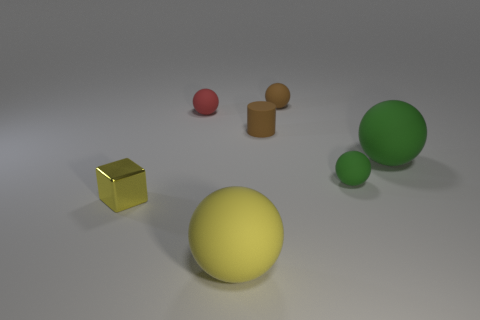Is the size of the brown rubber ball the same as the shiny object in front of the tiny brown rubber cylinder?
Offer a very short reply. Yes. The brown matte object that is in front of the tiny brown rubber sphere has what shape?
Your response must be concise. Cylinder. Is there any other thing that has the same shape as the yellow shiny object?
Offer a very short reply. No. Are there any rubber cubes?
Provide a short and direct response. No. Is the size of the brown rubber object in front of the red sphere the same as the rubber ball that is in front of the yellow metal cube?
Your response must be concise. No. What material is the small object that is in front of the red rubber thing and on the left side of the yellow matte sphere?
Provide a succinct answer. Metal. What number of spheres are right of the brown matte cylinder?
Keep it short and to the point. 3. There is another large ball that is made of the same material as the yellow sphere; what is its color?
Offer a very short reply. Green. Does the shiny object have the same shape as the small green thing?
Offer a terse response. No. What number of small objects are behind the brown cylinder and to the left of the large yellow matte ball?
Your answer should be very brief. 1. 